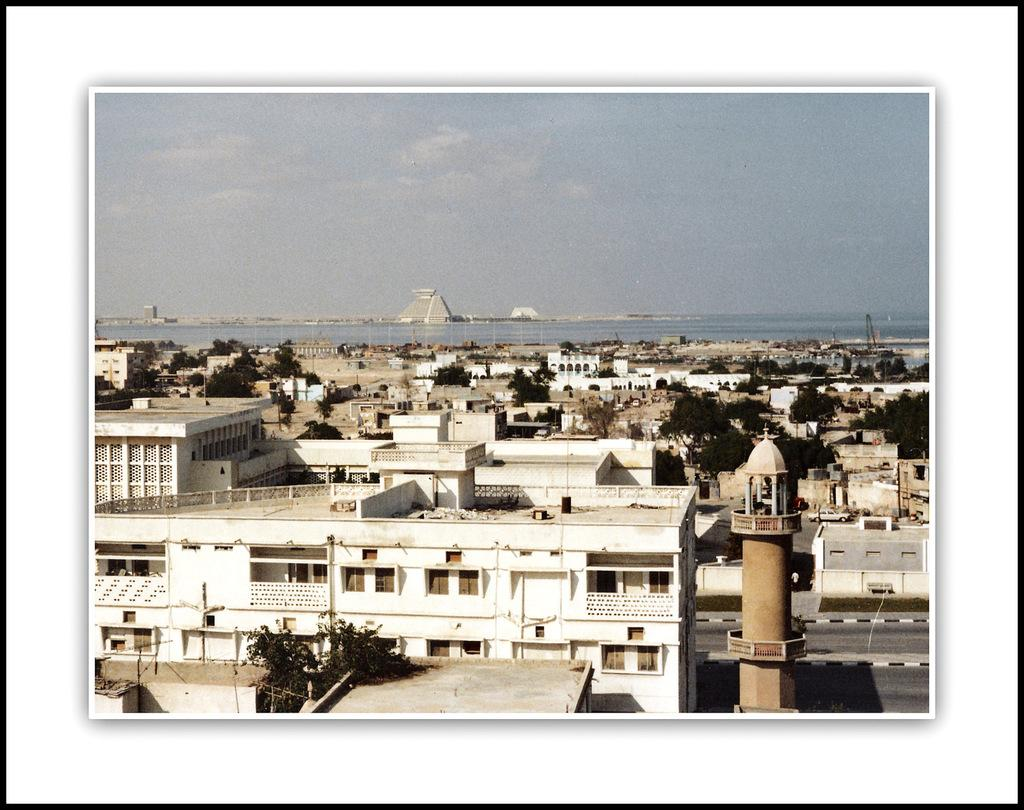What type of structures can be seen in the image? There are buildings in the image, including a mosque. What other natural elements are present in the image? There are trees and an ocean visible in the image. What is the purpose of the electrical pole in the image? The electrical pole has street lights. How many clams can be seen on the electrical pole in the image? There are no clams present on the electrical pole or anywhere else in the image. What ideas do the buildings in the image represent? The conversation does not discuss the ideas or symbolism represented by the buildings in the image. 